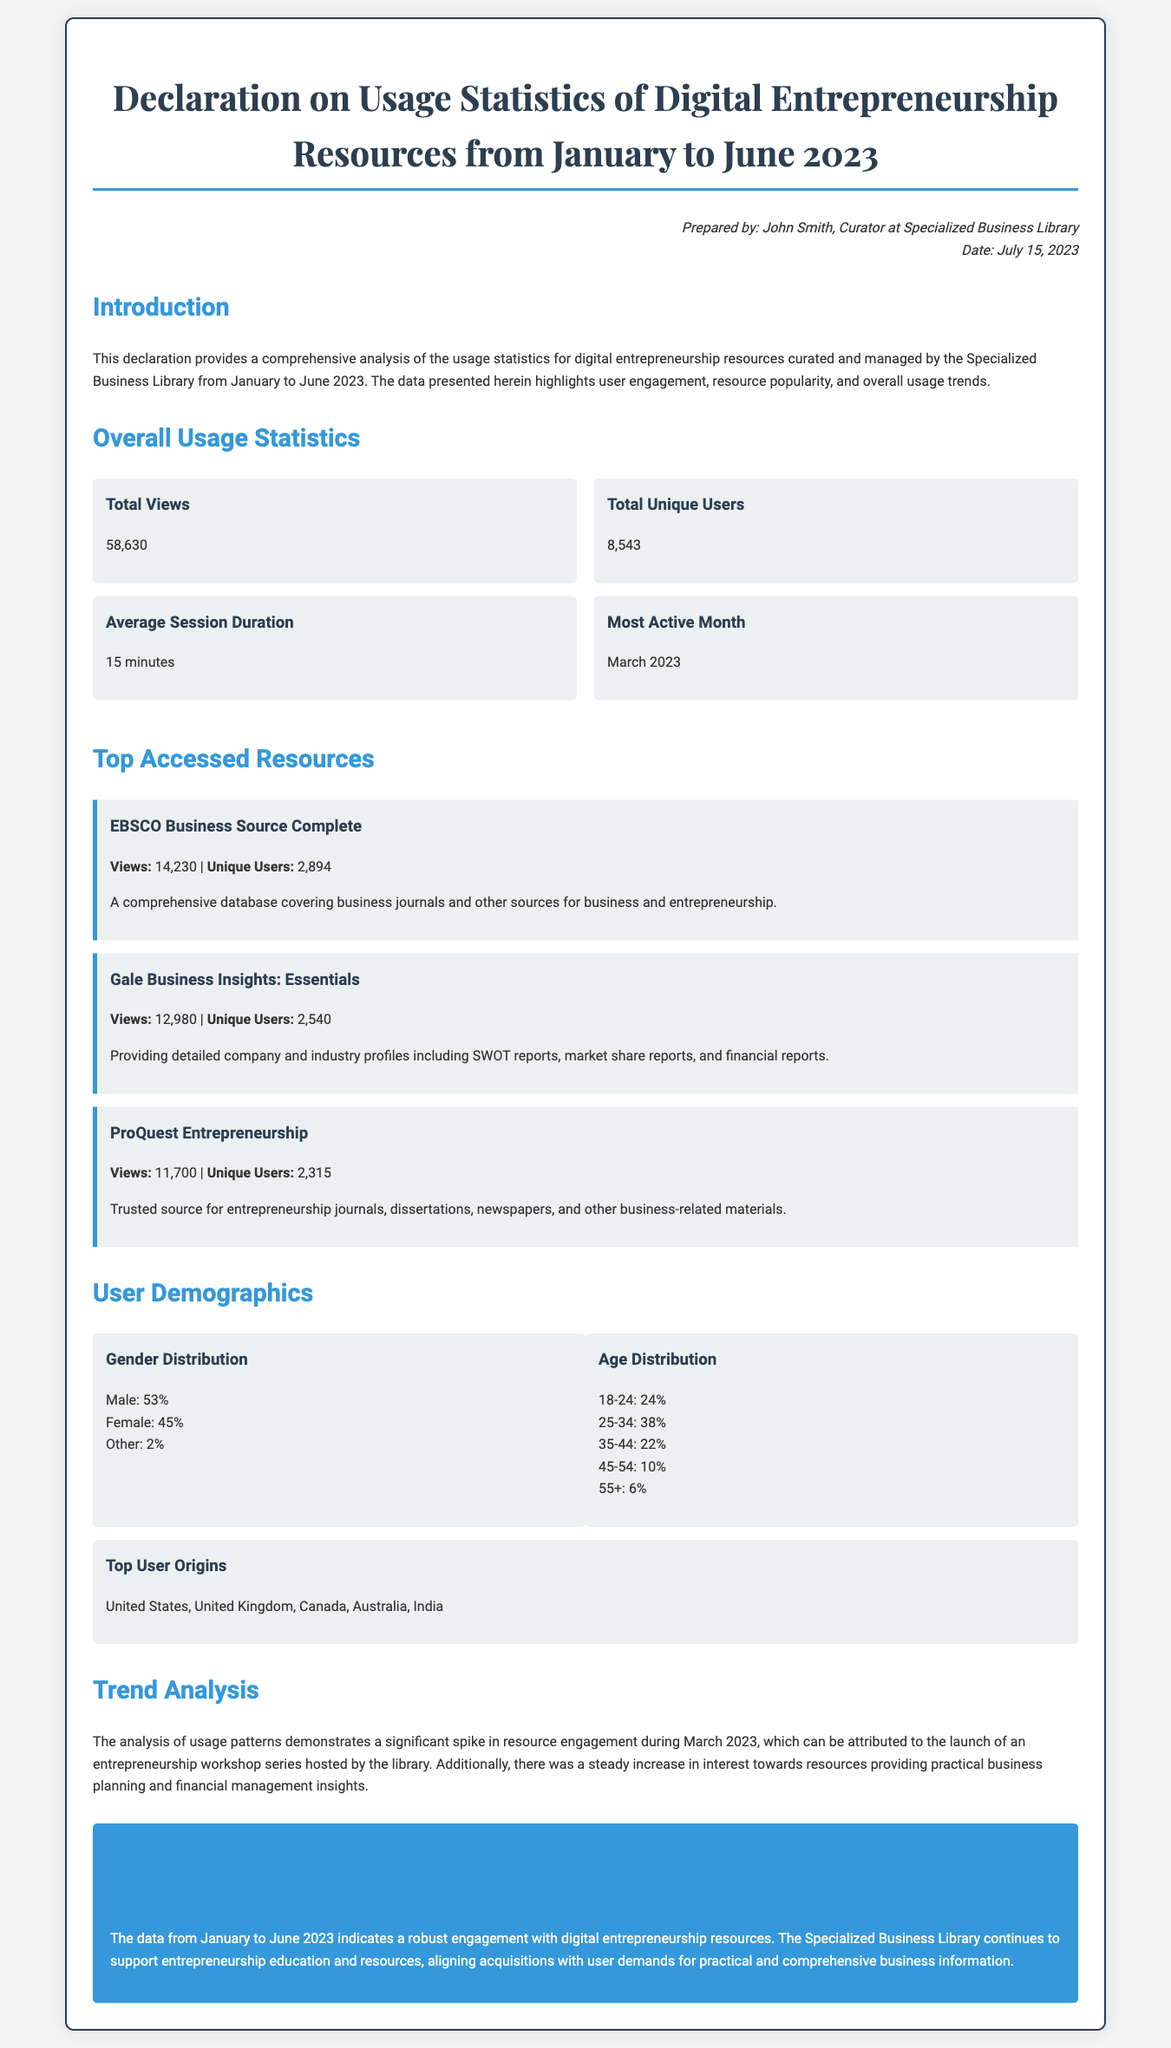What is the title of the document? The title of the document can be found at the top of the document, which describes its focus on usage statistics for digital entrepreneurship resources.
Answer: Declaration on Usage Statistics of Digital Entrepreneurship Resources from January to June 2023 Who prepared the document? The name of the person who prepared the document is mentioned in the prepared by section, indicating their role and affiliation.
Answer: John Smith How many total unique users were recorded? The total unique users statistic is presented under the overall usage statistics section of the document.
Answer: 8,543 Which month had the most activity? The month with the most activity is stated in the overall usage statistics section, specifically designated as the active month.
Answer: March 2023 What percentage of users are female? The gender distribution of users is detailed in the user demographics section, indicating the percentage of female users.
Answer: 45% What is the average session duration? The average session duration is specified in the overall usage statistics, reflecting user engagement duration.
Answer: 15 minutes Which resource had the highest number of views? The resource with the highest views is listed among the top accessed resources, providing a clear ranking of usage.
Answer: EBSCO Business Source Complete What was the primary reason for the spike in March 2023? The reason for the spike in resource engagement during March 2023 is discussed in the trend analysis section, relating to specific events hosted by the library.
Answer: Launch of an entrepreneurship workshop series 